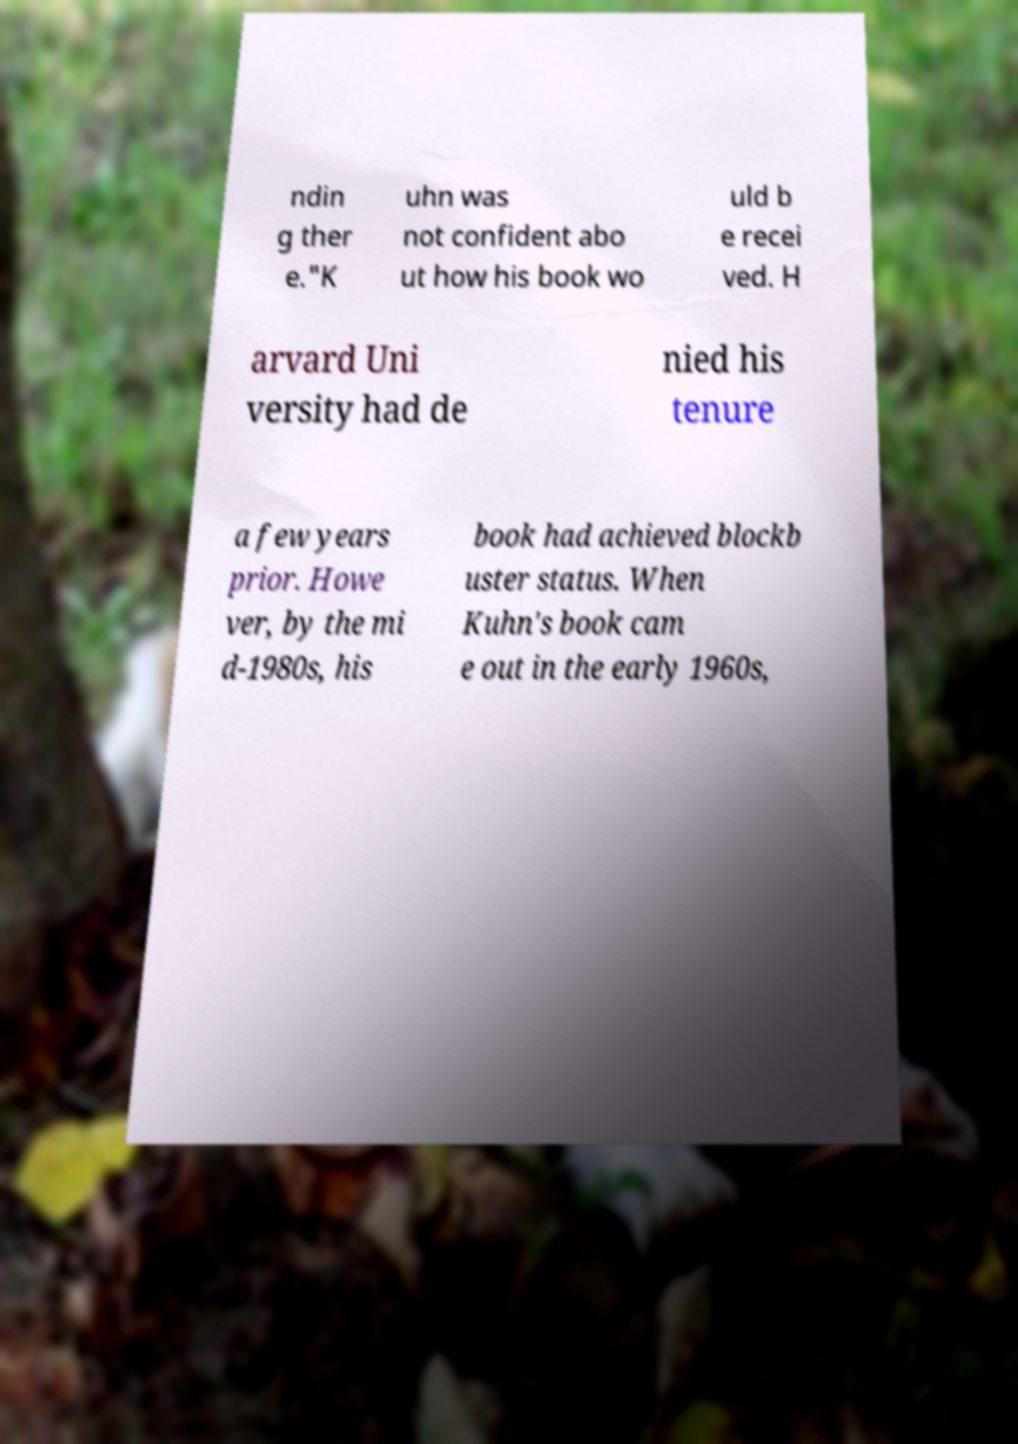There's text embedded in this image that I need extracted. Can you transcribe it verbatim? ndin g ther e."K uhn was not confident abo ut how his book wo uld b e recei ved. H arvard Uni versity had de nied his tenure a few years prior. Howe ver, by the mi d-1980s, his book had achieved blockb uster status. When Kuhn's book cam e out in the early 1960s, 